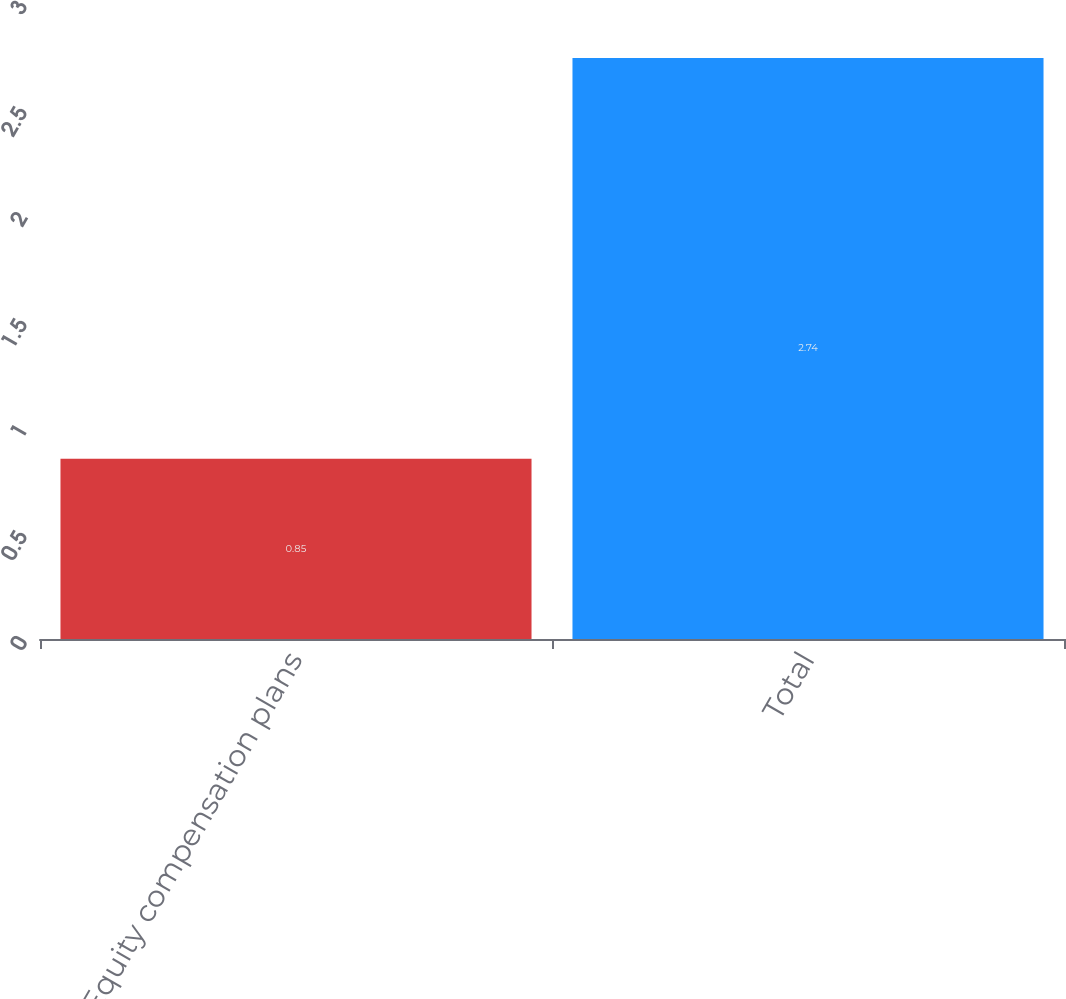Convert chart to OTSL. <chart><loc_0><loc_0><loc_500><loc_500><bar_chart><fcel>Equity compensation plans<fcel>Total<nl><fcel>0.85<fcel>2.74<nl></chart> 